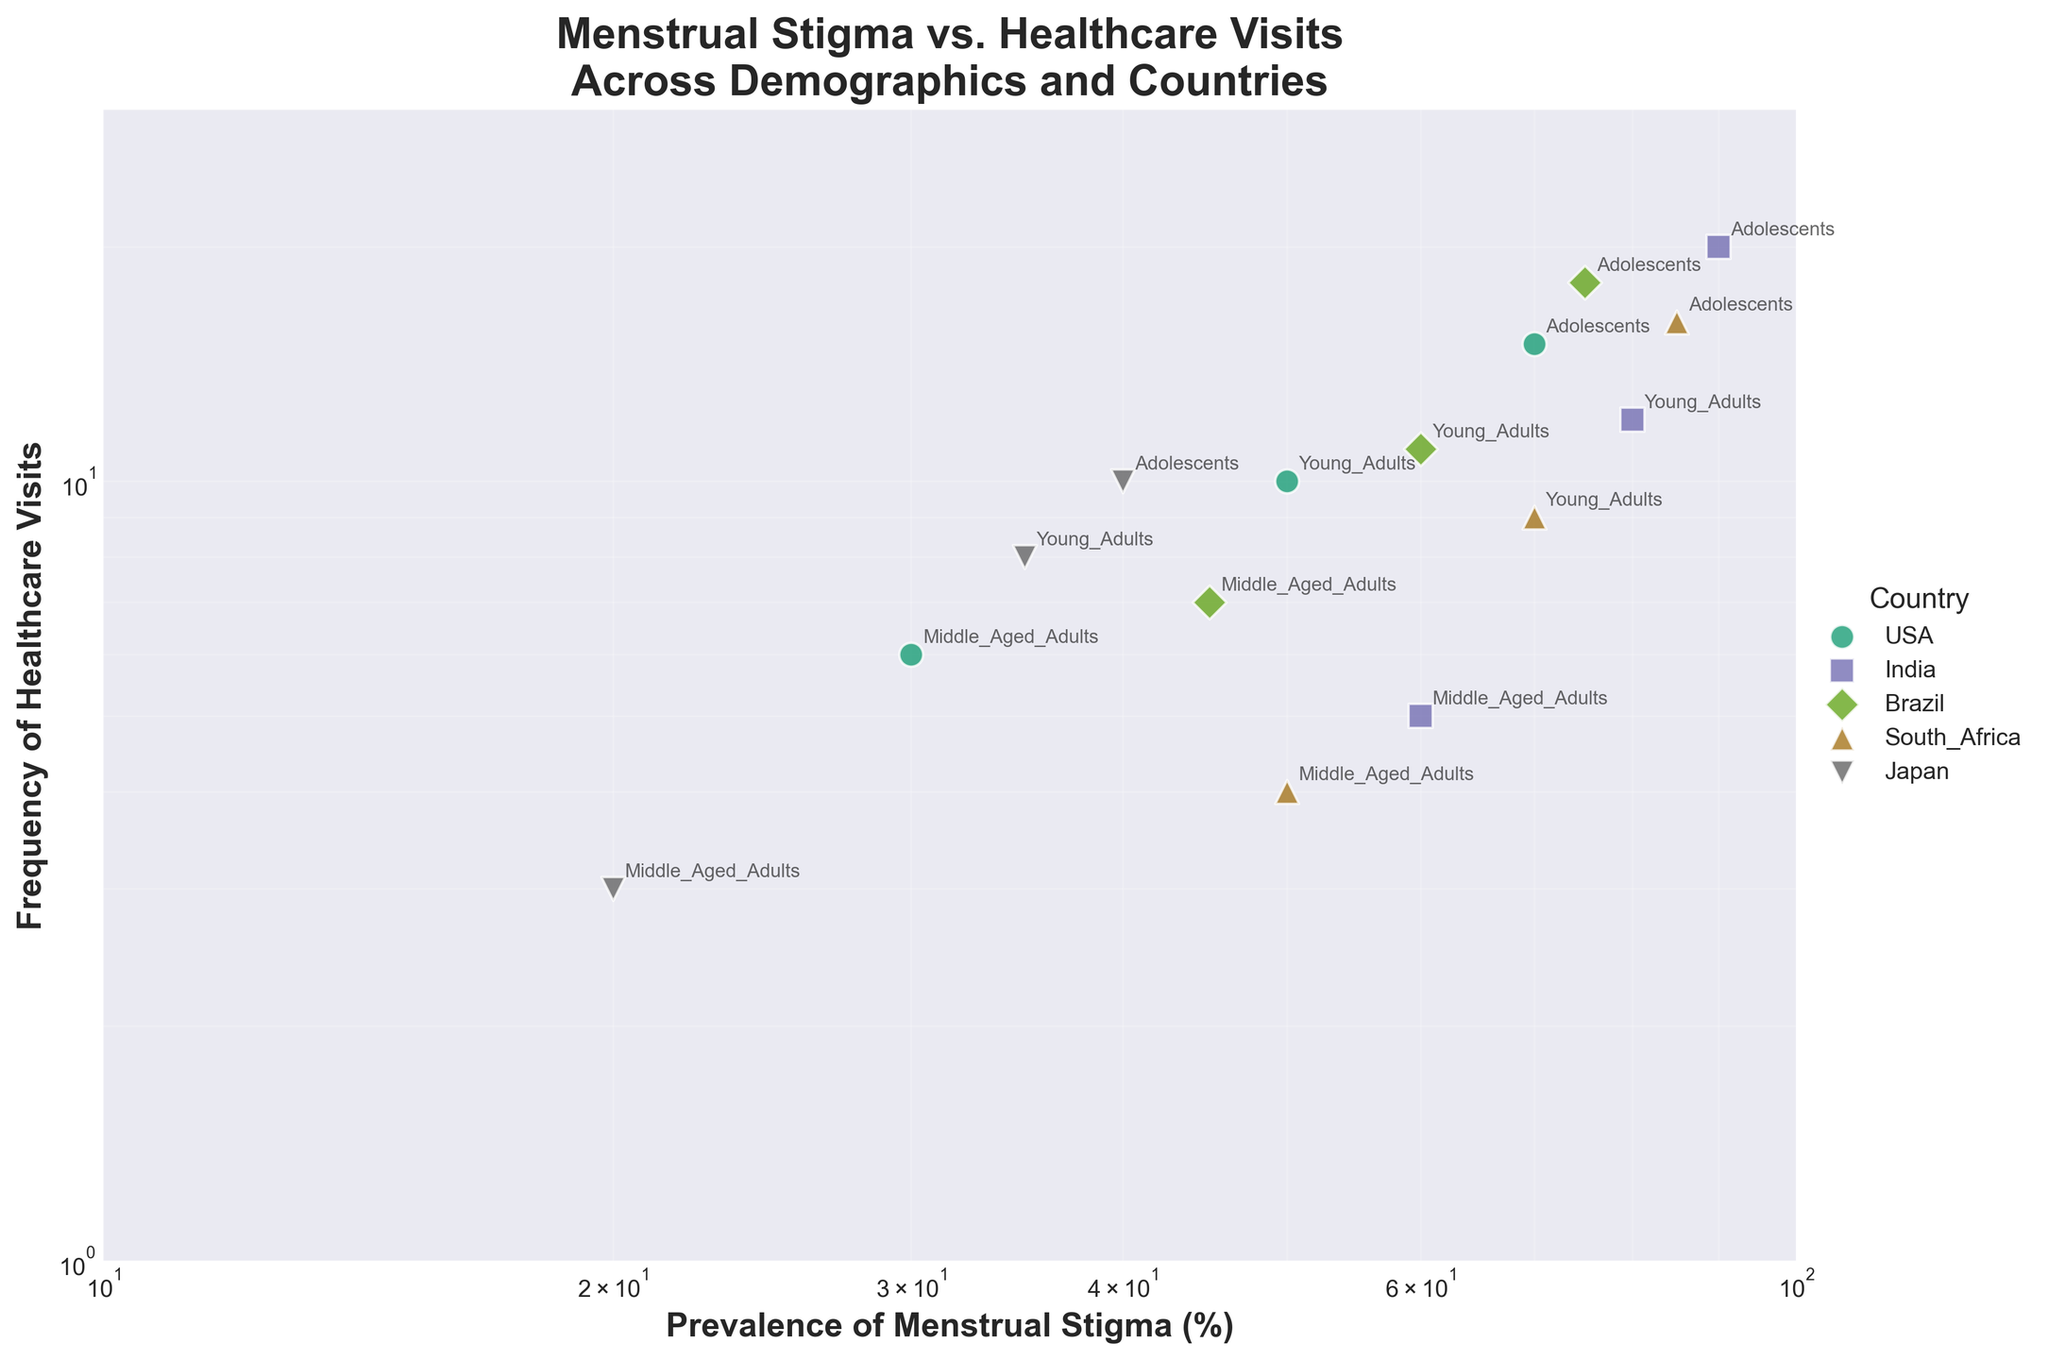what is the title of the figure? The title is situated at the top center of the figure. It states: "Menstrual Stigma vs. Healthcare Visits Across Demographics and Countries".
Answer: Menstrual Stigma vs. Healthcare Visits Across Demographics and Countries How many unique demographic groups are shown for each country? To determine this, look at the labels next to the data points for each country. There are three unique labels: Adolescents, Young Adults, and Middle_Aged_Adults.
Answer: 3 Which country has the highest prevalence of menstrual stigma among adolescents? Find the highest value on the x-axis for the 'Adolescents' demographic group. South Africa's adolescents have the highest prevalence of stigma at 85%.
Answer: South Africa What is the prevalence of menstrual stigma in middle-aged adults in Japan? Locate the data point for Japan's middle-aged adults on the x-axis. The value is 20%.
Answer: 20% Which demographic group in India has the highest frequency of healthcare visits? Look for the data points corresponding to India and check their y-axis values. Adolescents in India have the highest frequency with 20 visits.
Answer: Adolescents How many countries have a demographic group with a prevalence of menstrual stigma above 50%? Check the plotted data points and count the number of countries with at least one data point beyond the 50% mark on the x-axis. These countries are USA, India, Brazil, and South Africa.
Answer: 4 Which country has the lowest frequency of healthcare visits for any demographic group? Identify the country with the lowest point on the y-axis, which corresponds to Japan for middle-aged adults at 3 visits.
Answer: Japan Are there any demographic groups with a prevalence of menstrual stigma below 40%? Search for data points to the left of the 40% mark on the x-axis. There are demographic groups in Japan below 40%: Adolescents, Young Adults, and Middle-Aged Adults.
Answer: Yes On average, do adolescents or middle-aged adults have a higher prevalence of menstrual stigma across all countries? Calculate the average by summing the prevalence values for Adolescents and Middle-Aged Adults across all countries, then divide by the number of countries. Adolescents have higher average stigma (USA: 70, India: 90, Brazil: 75, South Africa: 85, Japan: 40; sum = 360, average = 72). Middle-Aged Adults are lower (USA: 30, India: 60, Brazil: 45, South Africa: 50, Japan: 20; sum = 205, average = 41).
Answer: Adolescents 